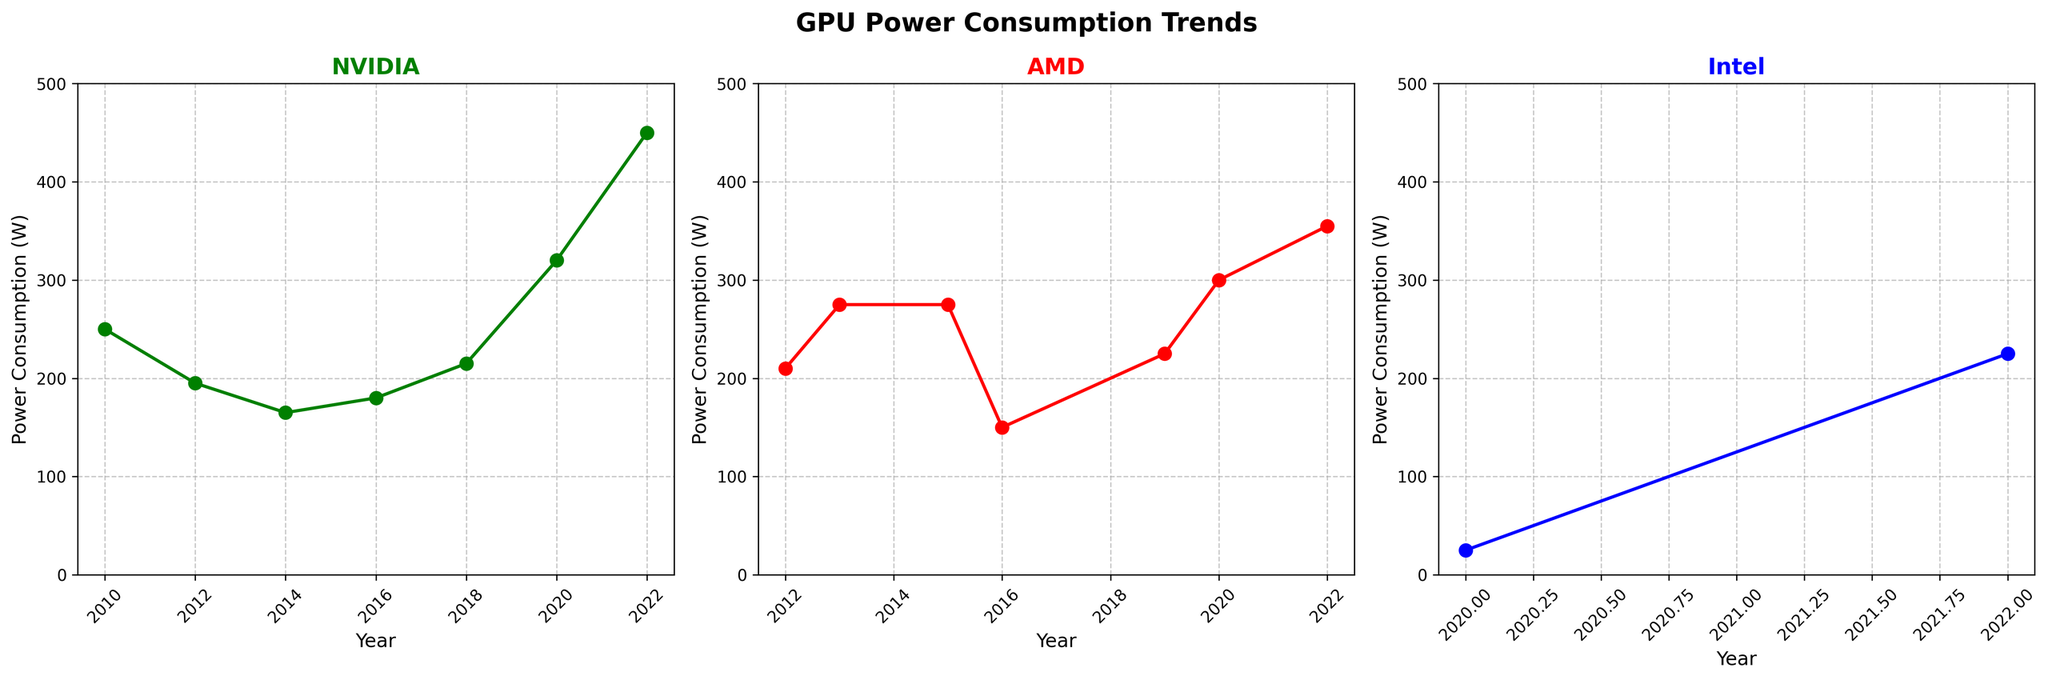What is the overall trend in power consumption for NVIDIA GPUs over the years? The plot for NVIDIA shows a generally increasing trend, with power consumption starting at 250W in 2010 and rising to 450W in 2022. Despite a dip around 2014 to 2016, the general trend is upwards.
Answer: Increasing Which GPU architecture has the lowest power consumption for Intel? According to the plot, Intel's Xe architecture in 2020 has the lowest power consumption at 25W.
Answer: Xe in 2020 How does the AMD GCN 4 architecture's power consumption in 2016 compare to AMD RNDA 3 architecture in 2022? The plot shows that AMD GCN 4's power consumption is much lower at 150W in 2016 compared to AMD RNDA 3's power at 355W in 2022.
Answer: Less than Which year saw the highest power consumption for AMD GPUs? The plot indicates that 2022 saw the highest power consumption for AMD GPUs at 355W with RDNA 3 architecture.
Answer: 2022 Identify the GPU architecture from NVIDIA and AMD with the highest power consumption and compare them. NVIDIA's Ada Lovelace in 2022 has the highest consumption at 450W, while AMD's RNDA 3 in 2022 has the highest at 355W. Ada Lovelace consumes more power than RDNA 3.
Answer: Ada Lovelace vs RDNA 3, Ada Lovelace more How does the power consumption in 2022 of Intel Arc compare with the earliest recorded NVIDIA architecture? Intel Arc in 2022 has a power consumption of 225W, which is less than NVIDIA's Fermi architecture in 2010 at 250W.
Answer: Less than What is the average power consumption of AMD GPUs from 2012 to 2015? Sum of AMD GPU power consumptions from 2012 (210W), 2013 (275W), and 2015 (275W) is 210 + 275 + 275 = 760W. There are 3 data points: 760 / 3 = 253.3W.
Answer: 253.3W Compare the power consumption trends of NVIDIA and AMD from 2016 onward. NVIDIA shows an increasing trend from 180W in 2016 to 450W in 2022, while AMD also increases but less steeply from 150W in 2016 to 355W in 2022. Both have rising trends but NVIDIA's rise is sharper.
Answer: Both increasing, NVIDIA sharper What is the difference in power consumption between the NVIDIA and AMD architectures released in 2020? In 2020, NVIDIA's Ampere has a power consumption of 320W, while AMD RDNA 2 has 300W. The difference is 320 - 300 = 20W.
Answer: 20W Which company shows the most stable trend in power consumption over the years? Intel shows the most stable trend, with only two data points, 25W in 2020 (Xe) and 225W in 2022 (Arc), and relatively minor variation compared to NVIDIA and AMD.
Answer: Intel 